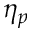Convert formula to latex. <formula><loc_0><loc_0><loc_500><loc_500>\eta _ { p }</formula> 